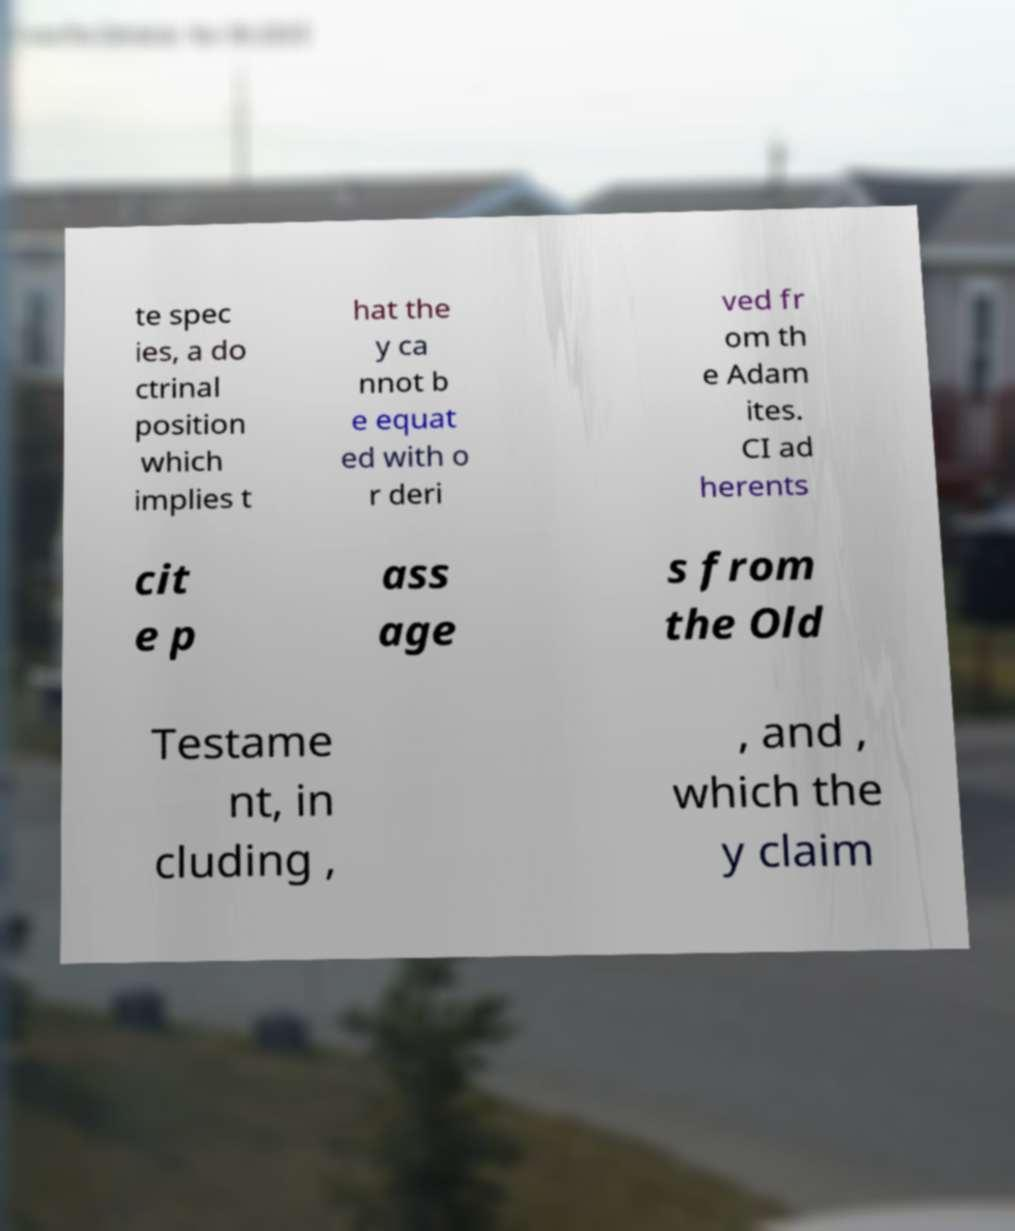Could you extract and type out the text from this image? te spec ies, a do ctrinal position which implies t hat the y ca nnot b e equat ed with o r deri ved fr om th e Adam ites. CI ad herents cit e p ass age s from the Old Testame nt, in cluding , , and , which the y claim 